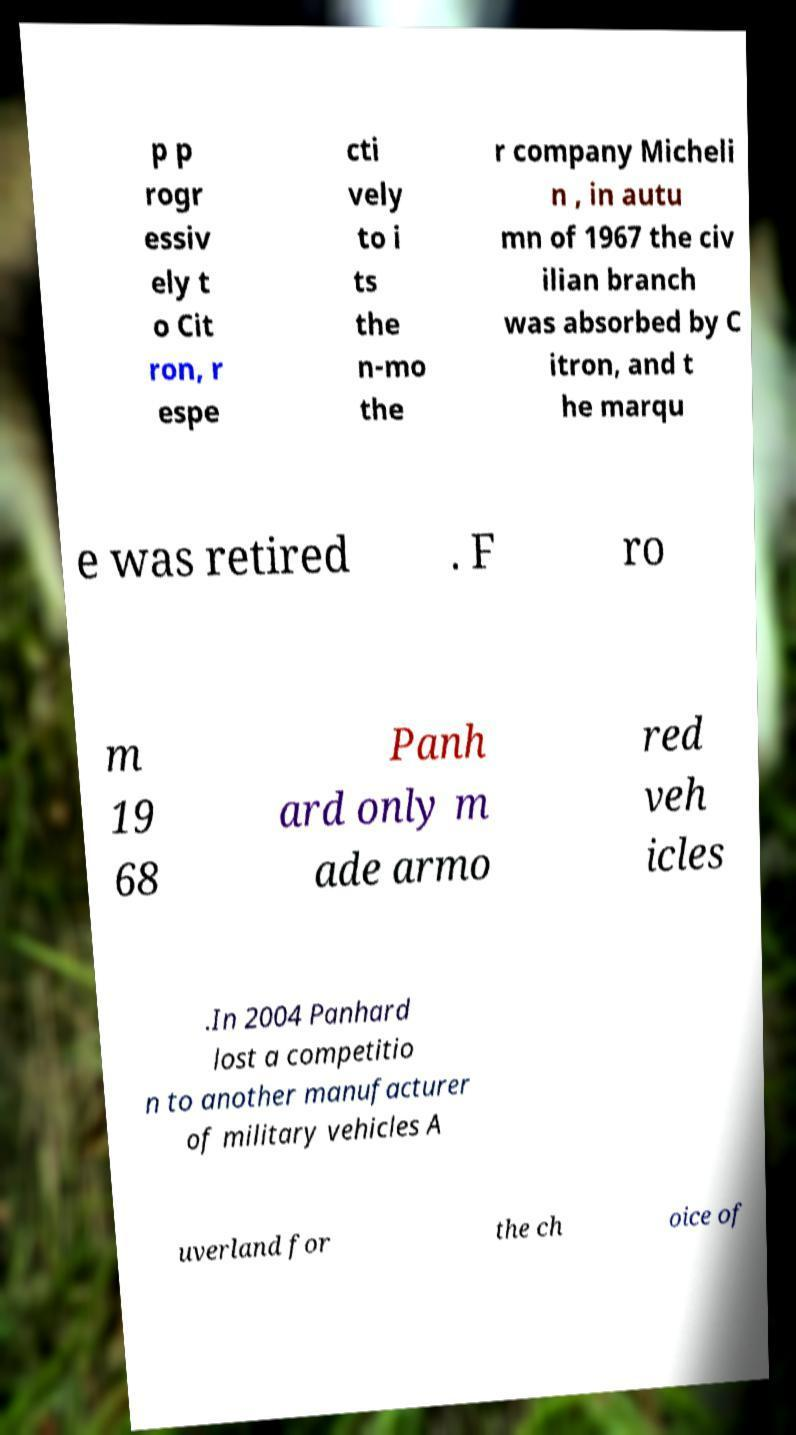I need the written content from this picture converted into text. Can you do that? p p rogr essiv ely t o Cit ron, r espe cti vely to i ts the n-mo the r company Micheli n , in autu mn of 1967 the civ ilian branch was absorbed by C itron, and t he marqu e was retired . F ro m 19 68 Panh ard only m ade armo red veh icles .In 2004 Panhard lost a competitio n to another manufacturer of military vehicles A uverland for the ch oice of 